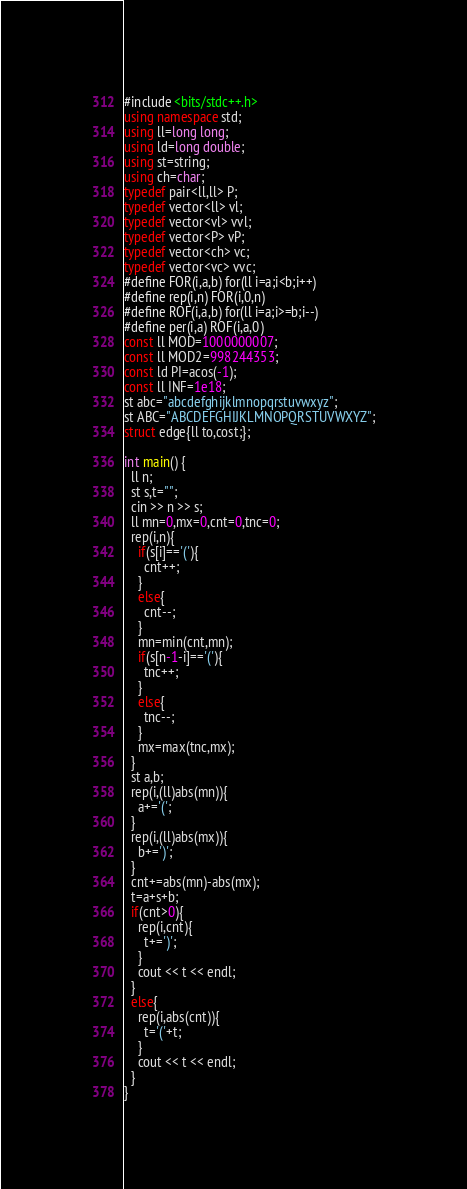<code> <loc_0><loc_0><loc_500><loc_500><_C++_>#include <bits/stdc++.h>
using namespace std;
using ll=long long;
using ld=long double;
using st=string;
using ch=char;
typedef pair<ll,ll> P;
typedef vector<ll> vl;
typedef vector<vl> vvl;
typedef vector<P> vP;
typedef vector<ch> vc;
typedef vector<vc> vvc;
#define FOR(i,a,b) for(ll i=a;i<b;i++)
#define rep(i,n) FOR(i,0,n)
#define ROF(i,a,b) for(ll i=a;i>=b;i--)
#define per(i,a) ROF(i,a,0)
const ll MOD=1000000007;
const ll MOD2=998244353;
const ld PI=acos(-1);
const ll INF=1e18;
st abc="abcdefghijklmnopqrstuvwxyz";
st ABC="ABCDEFGHIJKLMNOPQRSTUVWXYZ";
struct edge{ll to,cost;};

int main() {
  ll n;
  st s,t="";
  cin >> n >> s;
  ll mn=0,mx=0,cnt=0,tnc=0;
  rep(i,n){
    if(s[i]=='('){
      cnt++;
    }
    else{
      cnt--;
    }
    mn=min(cnt,mn);
    if(s[n-1-i]=='('){
      tnc++;
    }
    else{
      tnc--;
    }
    mx=max(tnc,mx);
  }
  st a,b;
  rep(i,(ll)abs(mn)){
    a+='(';
  }
  rep(i,(ll)abs(mx)){
    b+=')';
  }
  cnt+=abs(mn)-abs(mx);
  t=a+s+b;
  if(cnt>0){
    rep(i,cnt){
      t+=')';
    }
    cout << t << endl;
  }
  else{
    rep(i,abs(cnt)){
      t='('+t;
    }
    cout << t << endl;
  }
}</code> 